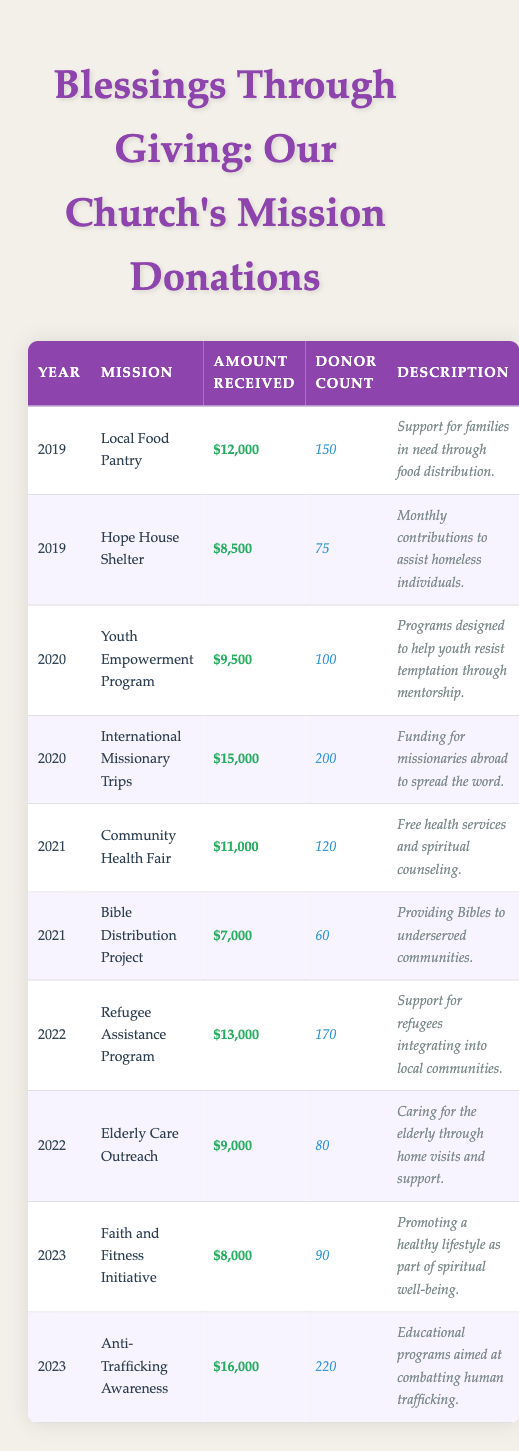What was the total amount received for the Local Food Pantry in 2019? The table shows that the amount received for the Local Food Pantry in 2019 was $12,000.
Answer: $12,000 How many donors contributed to the Anti-Trafficking Awareness mission in 2023? The table indicates that the donor count for the Anti-Trafficking Awareness mission in 2023 was 220.
Answer: 220 Which mission received the highest amount in 2020? Looking at the amounts for 2020, the International Missionary Trips received $15,000, which is the highest compared to the Youth Empowerment Program, which received $9,500.
Answer: International Missionary Trips What is the average amount received for all missions in 2022? The amounts received in 2022 were $13,000 for the Refugee Assistance Program and $9,000 for the Elderly Care Outreach. Summing them gives $13,000 + $9,000 = $22,000. Dividing by 2 (the number of missions) results in an average of $22,000 / 2 = $11,000.
Answer: $11,000 Did the donations for the Community Health Fair exceed those for the Bible Distribution Project in 2021? The Community Health Fair received $11,000, while the Bible Distribution Project received $7,000. Since $11,000 is greater than $7,000, the statement is true.
Answer: Yes What was the combined total amount received by the church missions in 2019? The total for 2019 includes $12,000 for the Local Food Pantry and $8,500 for the Hope House Shelter. Adding these amounts gives $12,000 + $8,500 = $20,500.
Answer: $20,500 In which year did the Youth Empowerment Program receive $9,500? The table specifies that the Youth Empowerment Program received $9,500 in the year 2020.
Answer: 2020 Which mission had the lowest donor count in 2021? The Bible Distribution Project had the lowest donor count of 60 compared to the Community Health Fair which had 120 donors in the same year.
Answer: Bible Distribution Project What is the difference in amount received between the Refugee Assistance Program and Elderly Care Outreach in 2022? The Refugee Assistance Program received $13,000 while the Elderly Care Outreach received $9,000. The difference is calculated as $13,000 - $9,000 = $4,000.
Answer: $4,000 What percentage of the total donations in 2023 was received by the Anti-Trafficking Awareness mission? In 2023, the total donations were $8,000 + $16,000 = $24,000. The Anti-Trafficking Awareness received $16,000. The percentage is ($16,000 / $24,000) * 100 = 66.67%.
Answer: 66.67% 